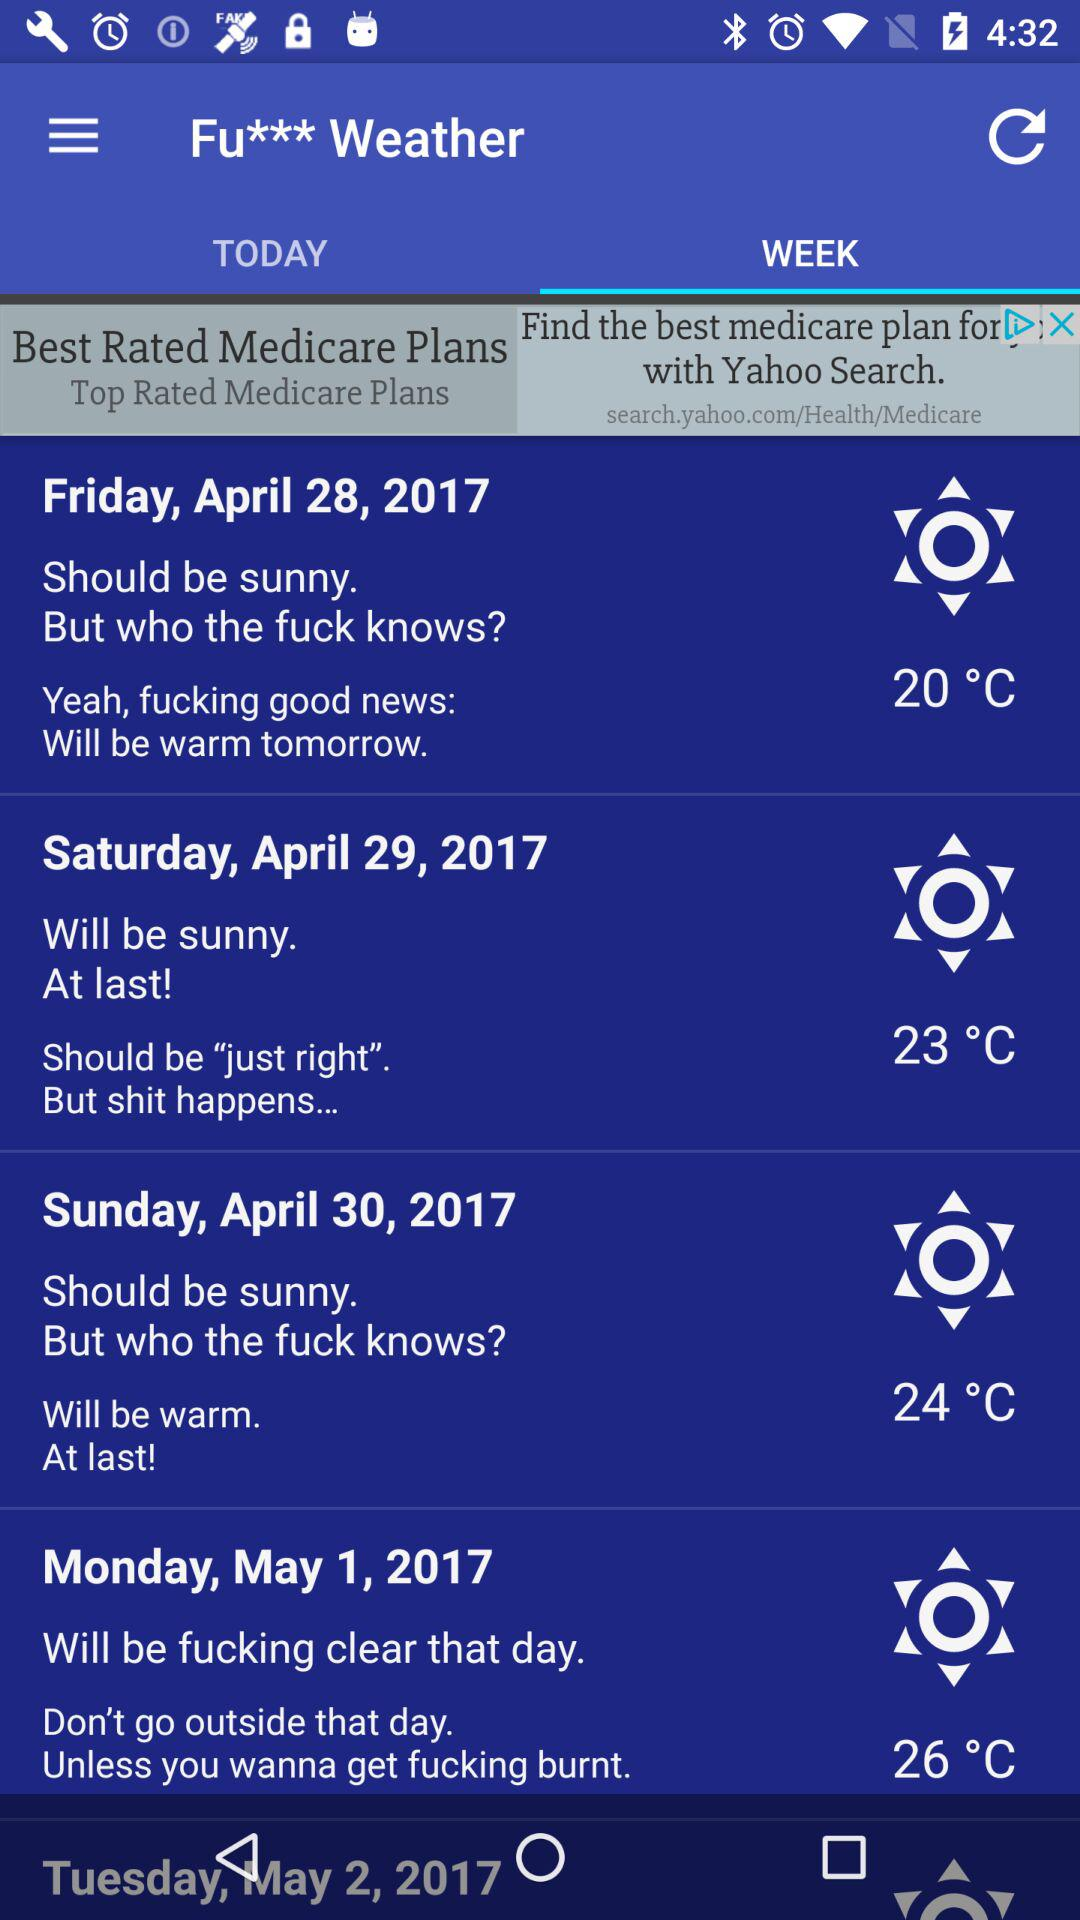Which is the day maximum temperature?
When the provided information is insufficient, respond with <no answer>. <no answer> 